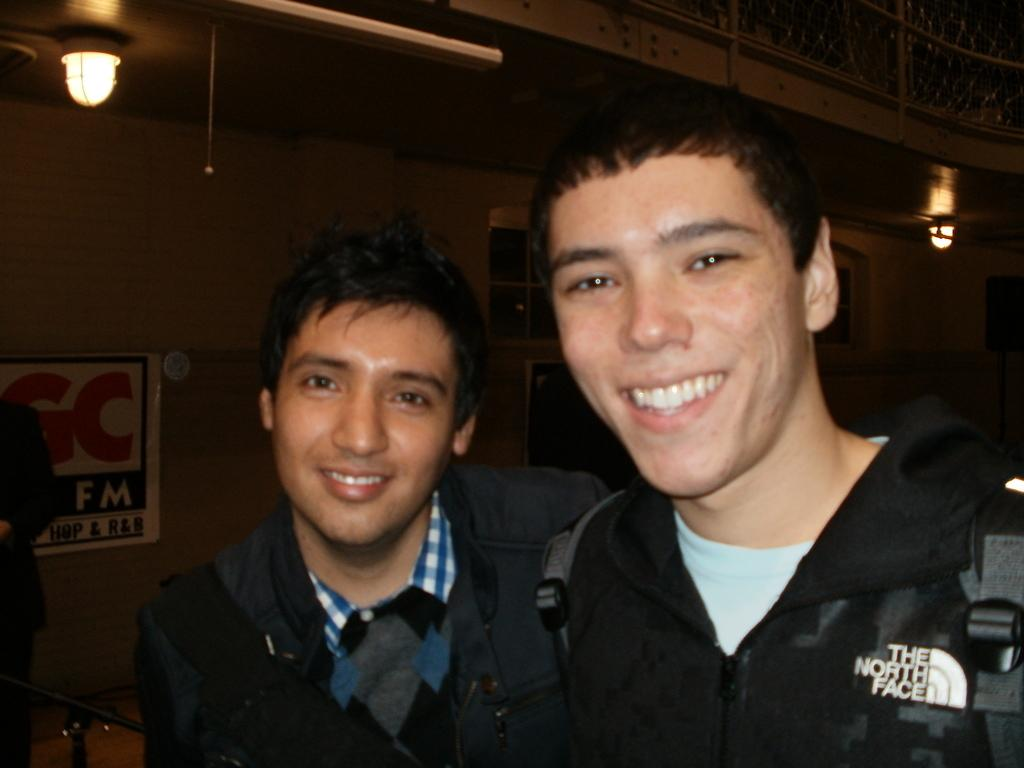How many people are in the image? There are two people standing in the center of the image. What is the people doing in the image? The people are smiling. What can be seen in the background of the image? There is a wall and windows in the background of the image. What is located on the left side of the image? There is a board on the left side of the image. What is visible at the top of the image? There are lights visible at the top of the image. What type of lunchroom is visible in the image? There is no lunchroom present in the image. What team are the people in the image a part of? The image does not provide any information about the people being part of a team. Is there a secretary visible in the image? There is no secretary present in the image. 